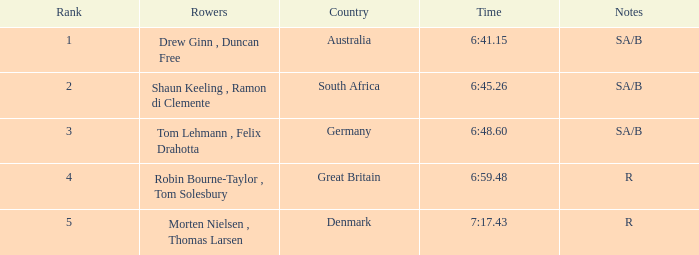What was the duration for the rowers representing great britain? 6:59.48. I'm looking to parse the entire table for insights. Could you assist me with that? {'header': ['Rank', 'Rowers', 'Country', 'Time', 'Notes'], 'rows': [['1', 'Drew Ginn , Duncan Free', 'Australia', '6:41.15', 'SA/B'], ['2', 'Shaun Keeling , Ramon di Clemente', 'South Africa', '6:45.26', 'SA/B'], ['3', 'Tom Lehmann , Felix Drahotta', 'Germany', '6:48.60', 'SA/B'], ['4', 'Robin Bourne-Taylor , Tom Solesbury', 'Great Britain', '6:59.48', 'R'], ['5', 'Morten Nielsen , Thomas Larsen', 'Denmark', '7:17.43', 'R']]} 